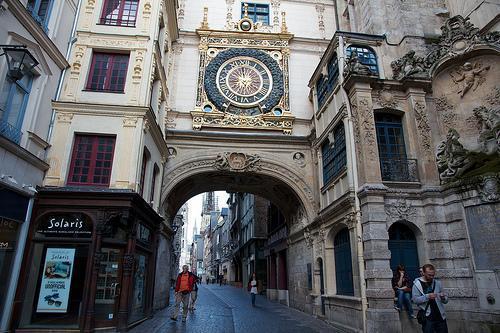How many clocks are in the photo?
Give a very brief answer. 1. How many people in red shirts are in the photo?
Give a very brief answer. 1. How many people are wearing grey sweat jackets with hoods in the photo?
Give a very brief answer. 1. 